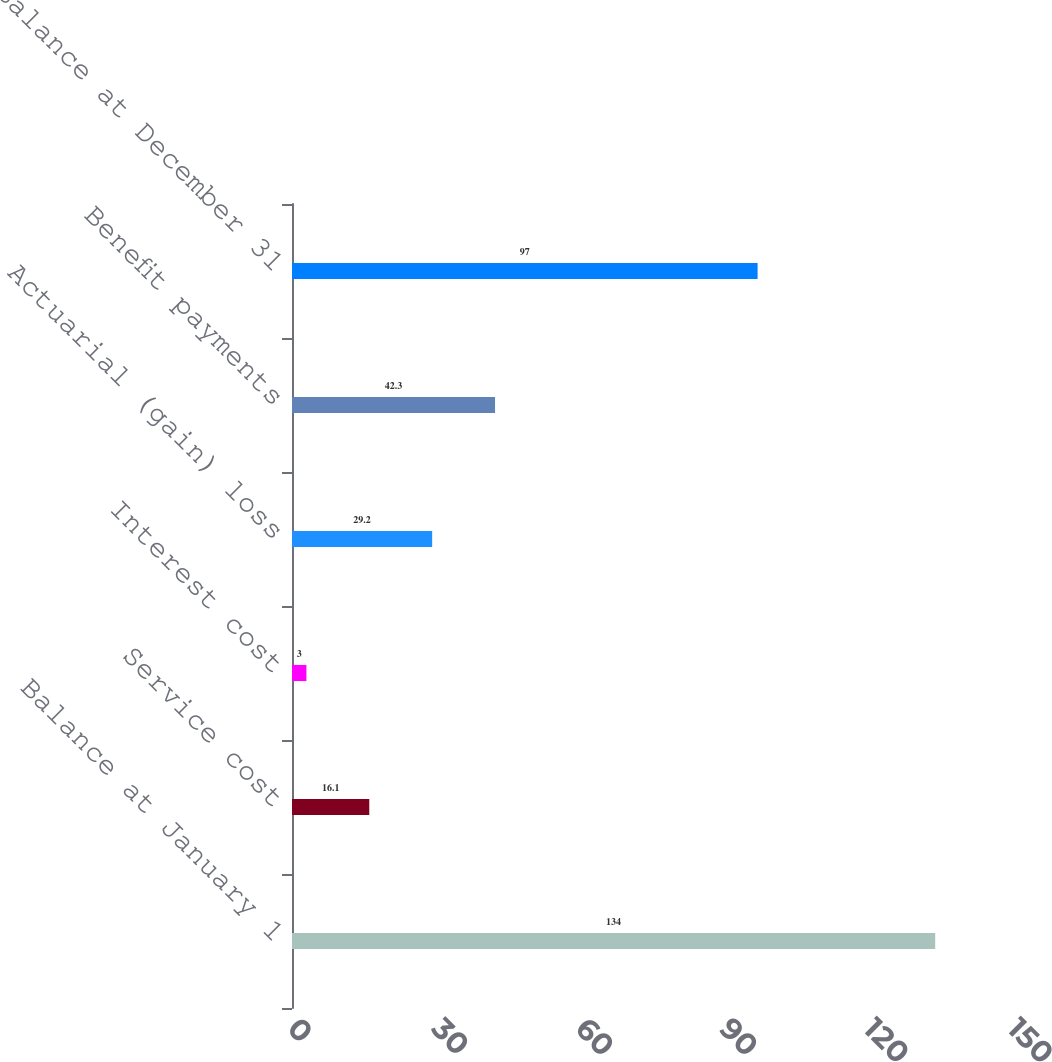Convert chart to OTSL. <chart><loc_0><loc_0><loc_500><loc_500><bar_chart><fcel>Balance at January 1<fcel>Service cost<fcel>Interest cost<fcel>Actuarial (gain) loss<fcel>Benefit payments<fcel>Balance at December 31<nl><fcel>134<fcel>16.1<fcel>3<fcel>29.2<fcel>42.3<fcel>97<nl></chart> 